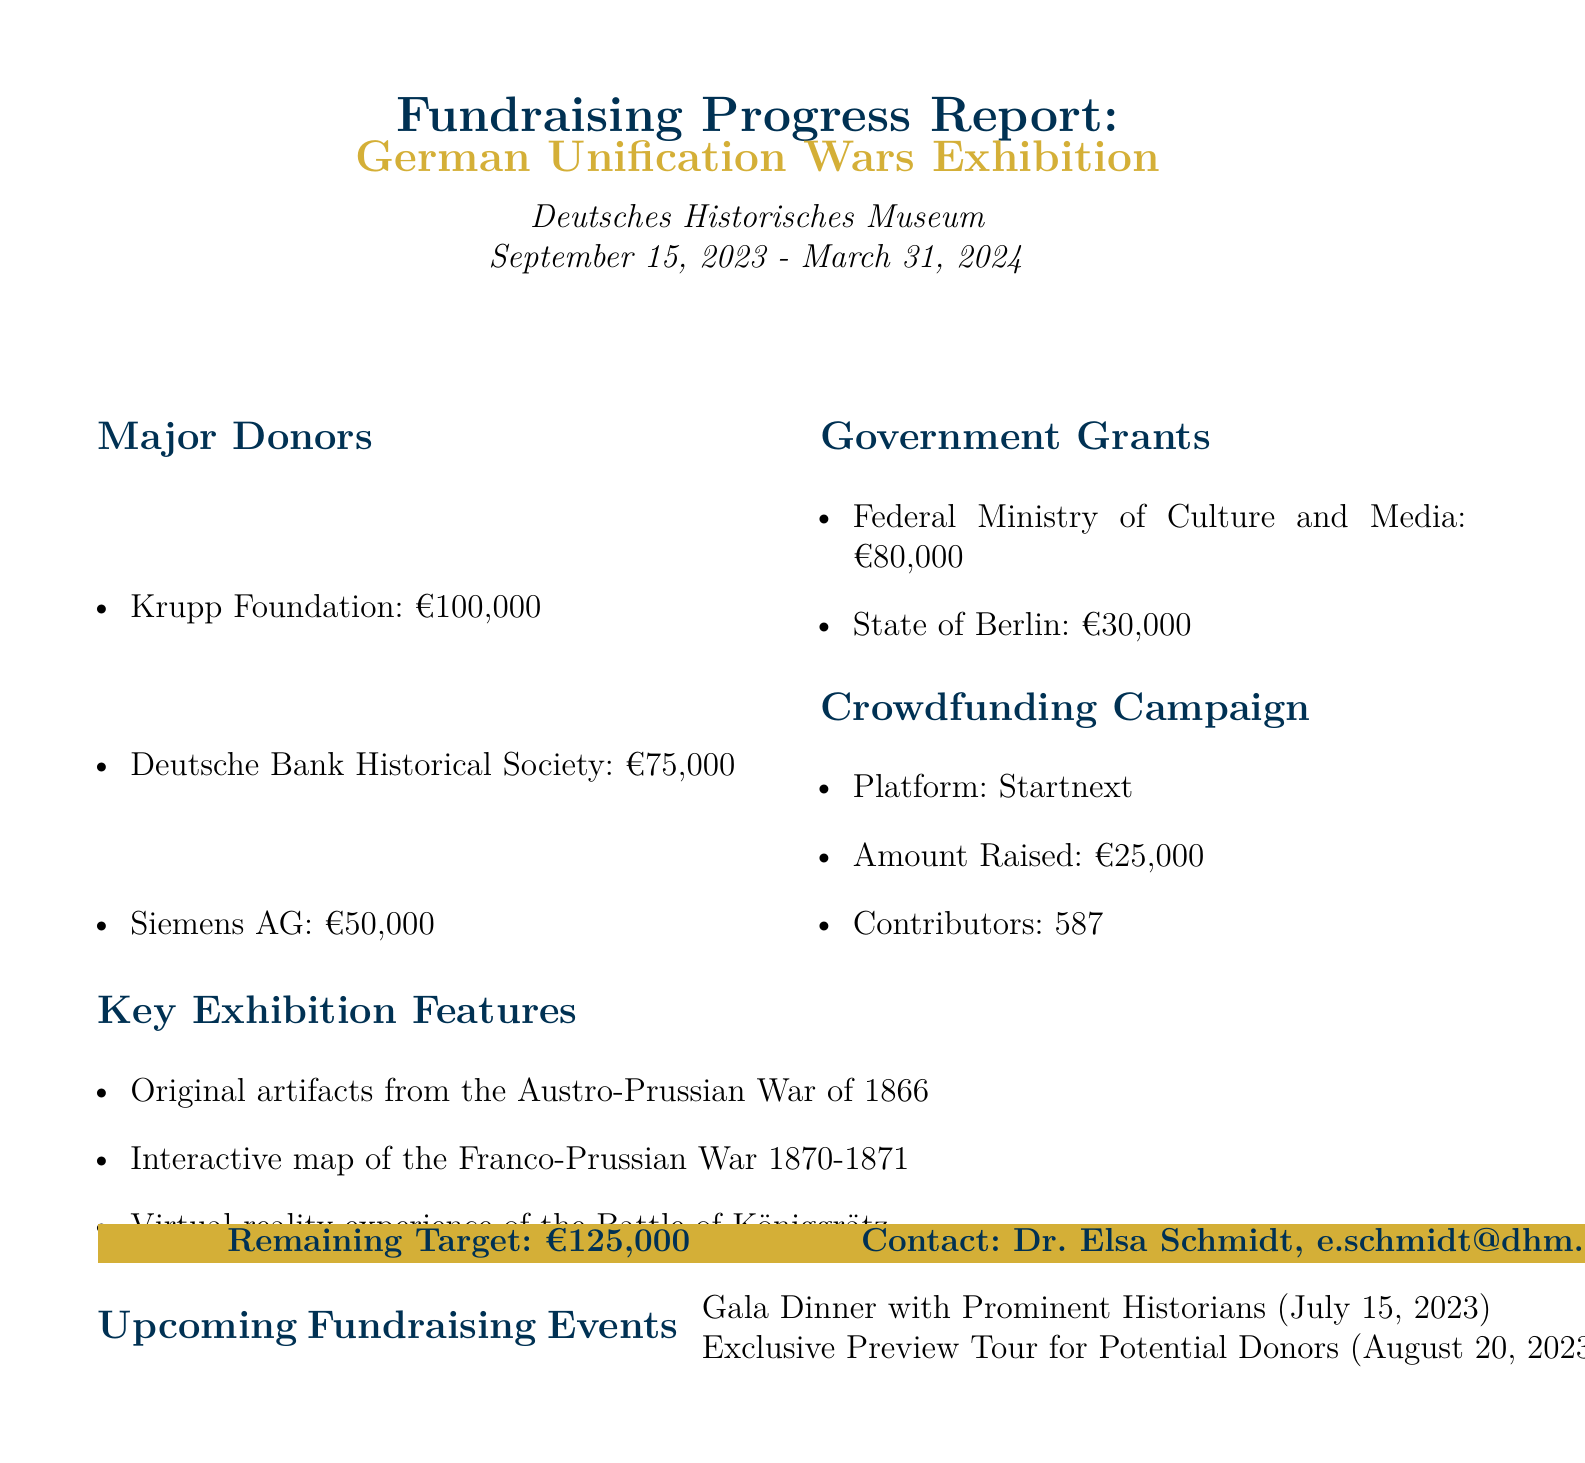What is the fundraising goal? The fundraising goal is clearly stated in the report as €500,000.
Answer: €500,000 How much has been raised so far? The current total raised amount is specified as €375,000.
Answer: €375,000 Who is the major donor that contributed €100,000? The document lists the major donors, with the Krupp Foundation contributing €100,000.
Answer: Krupp Foundation What is the remaining target amount? The report indicates the remaining target as €125,000.
Answer: €125,000 What percentage of the fundraising goal has been completed? The report notes that 75% of the fundraising goal has been reached.
Answer: 75% What is the date of the first upcoming fundraising event? The document provides the date for the first fundraising event, which is July 15, 2023.
Answer: July 15, 2023 How much is expected to be raised from the Gala Dinner? The expected revenue from the Gala Dinner is detailed as €40,000.
Answer: €40,000 Which platform is used for the crowdfunding campaign? The report specifies that the crowdfunding campaign is on the Startnext platform.
Answer: Startnext What are two key exhibition features mentioned? The report lists several key features, including original artifacts from the Austro-Prussian War and a virtual reality experience of the Battle of Königgrätz.
Answer: Original artifacts from the Austro-Prussian War of 1866, Virtual reality experience of the Battle of Königgrätz 